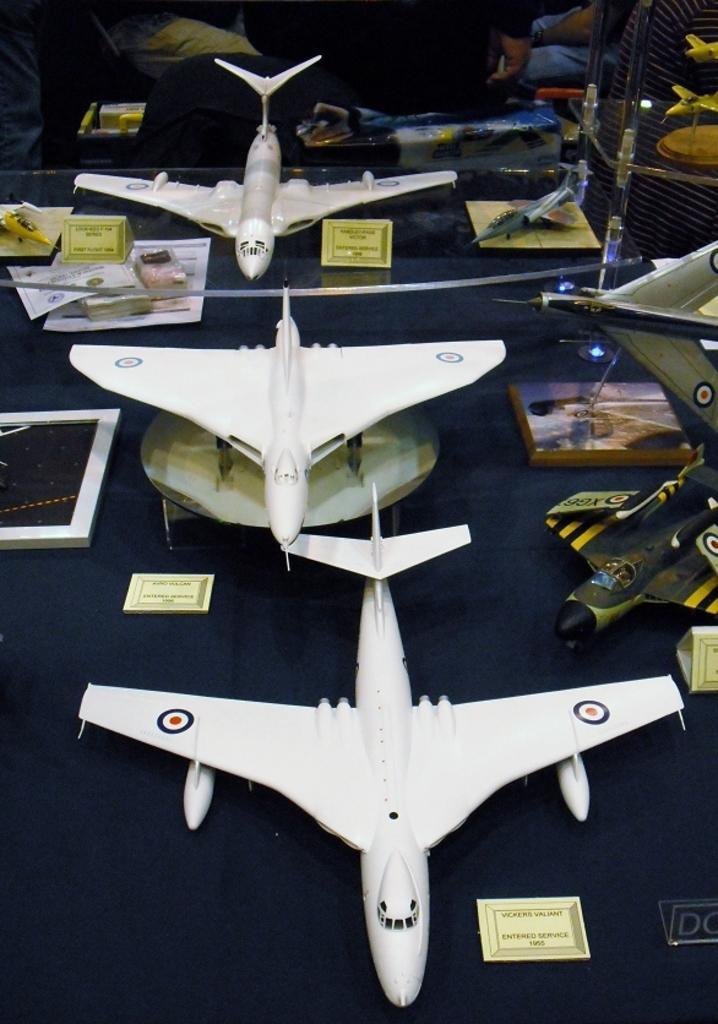Describe this image in one or two sentences. In this image, we can see aircrafts and boards on the table. In the background, there are some people. 